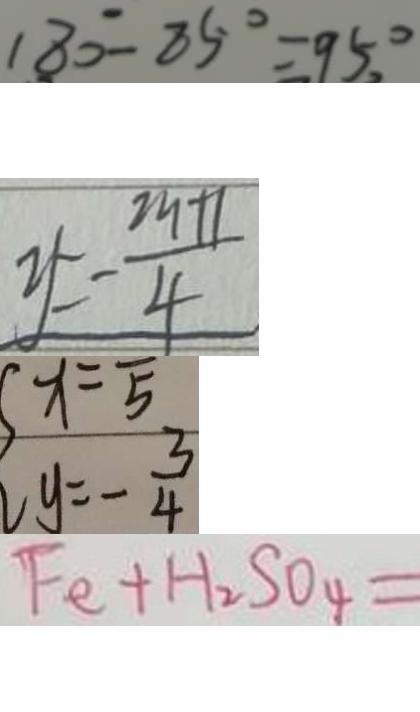<formula> <loc_0><loc_0><loc_500><loc_500>1 8 0 ^ { \circ } - 8 5 ^ { \circ } = 9 5 ^ { \circ } , 
 y = - \frac { 2 9 + 1 } { 4 } 
 y = - \frac { 3 } { 4 } 
 F e + H _ { 2 } S O _ { 4 } =</formula> 